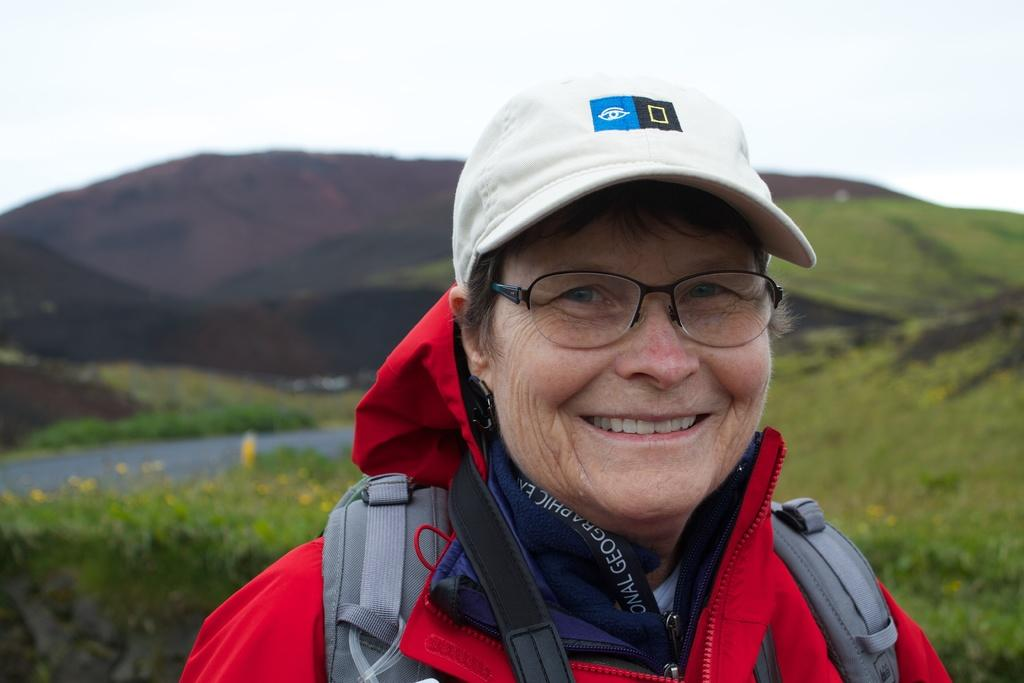Who is the main subject in the image? There is a woman in the image. What is the woman wearing? The woman is wearing a red dress, a backpack, and a cap. What can be seen behind the woman? There is greenery behind the woman. What is visible in the distance in the image? There are mountains in the background of the image. Who is the owner of the snow in the image? There is no snow present in the image, so it is not possible to determine an owner. 